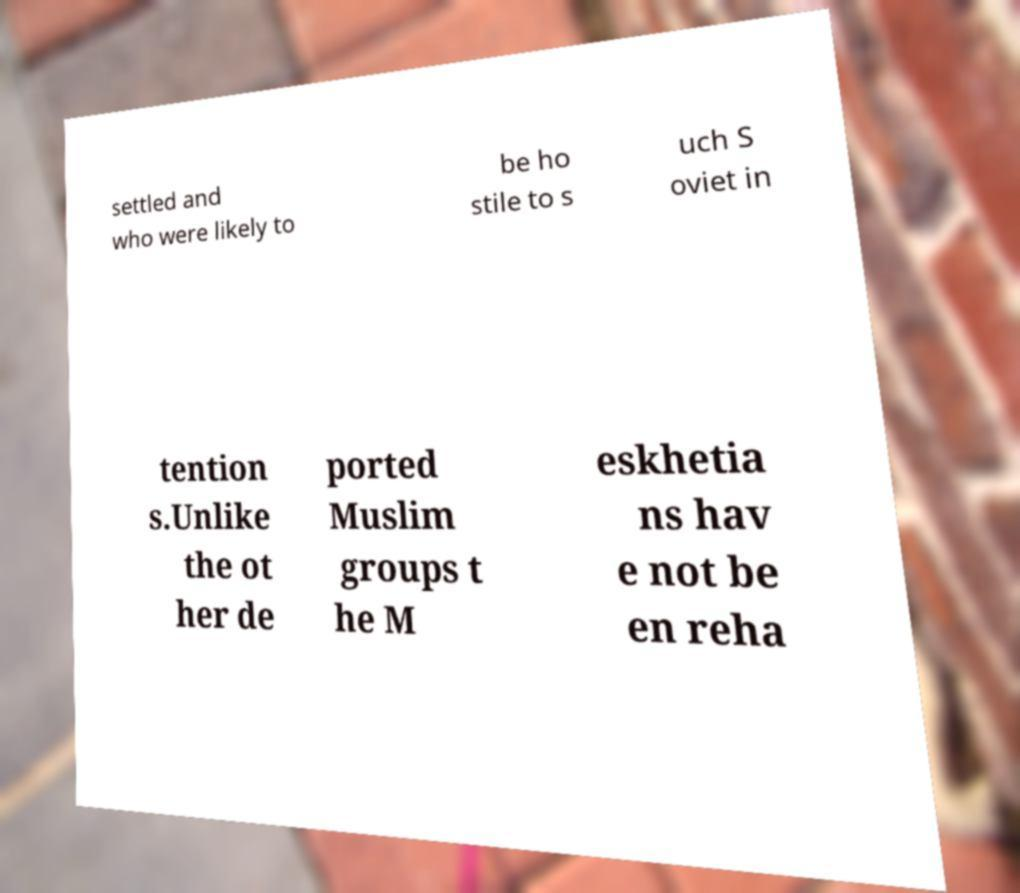Can you accurately transcribe the text from the provided image for me? settled and who were likely to be ho stile to s uch S oviet in tention s.Unlike the ot her de ported Muslim groups t he M eskhetia ns hav e not be en reha 